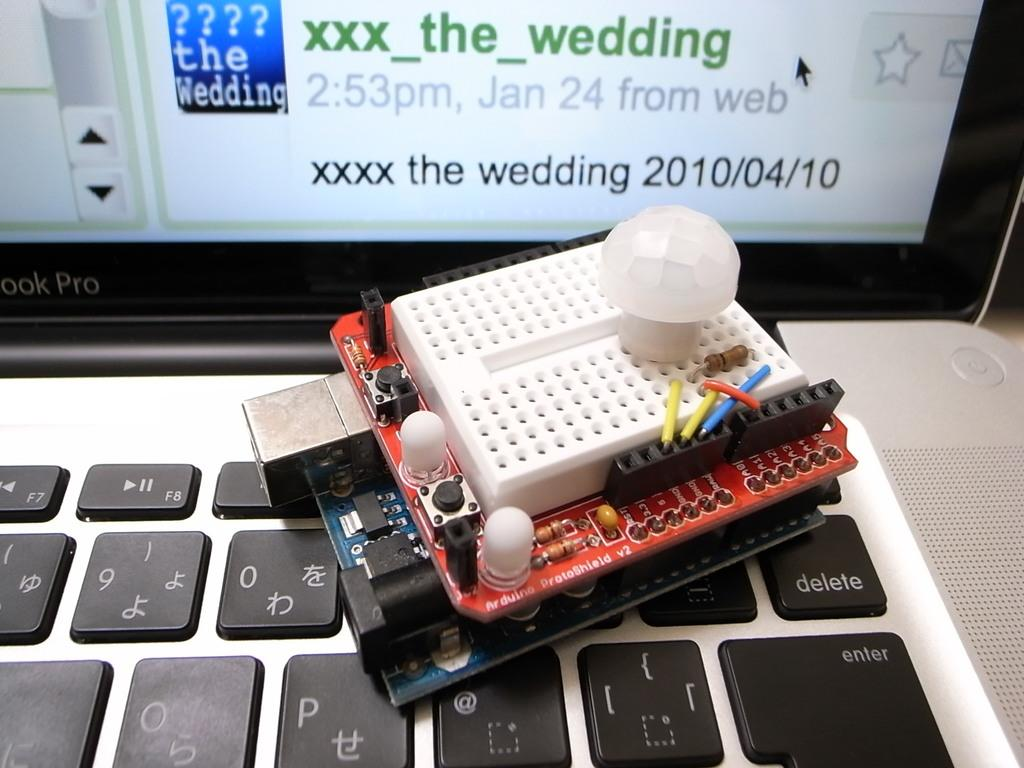What is the primary object in the image? There is a screen in the image. What is located near the screen? There is a keyboard in the image. What other component can be seen in the image? There is an electric circuit in the image. What type of canvas is visible in the image? There is no canvas present in the image. What kind of noise can be heard coming from the screen in the image? The image is static, so no noise can be heard from the screen. 